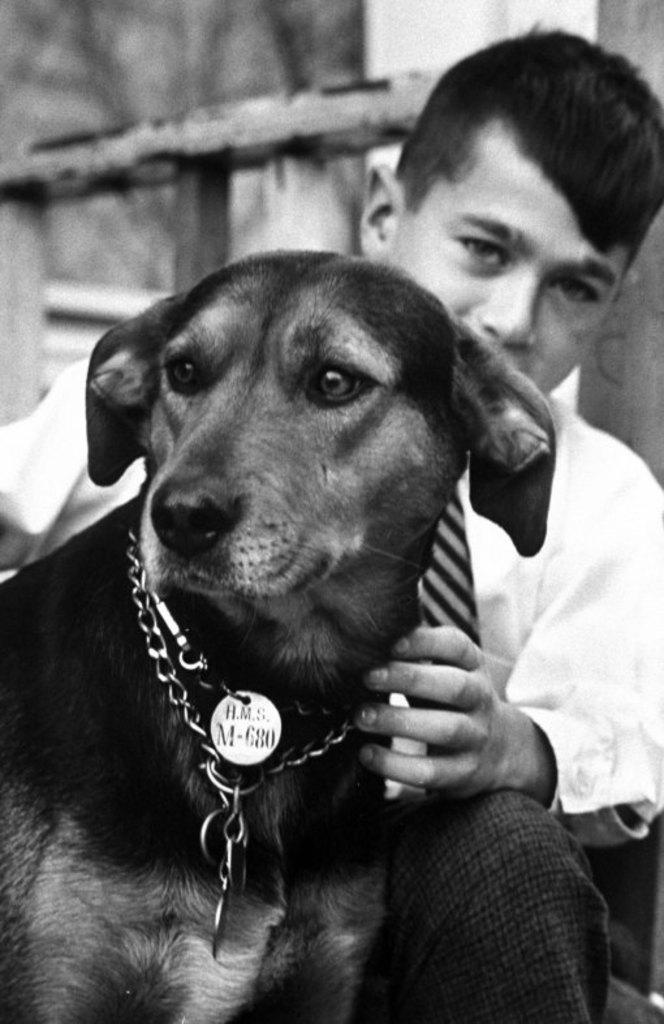What is the color scheme of the image? The image is black and white. Who or what can be seen in the image? There is a boy and a dog in the image. What is the boy doing in the image? The boy is touching the dog. What type of plants can be seen growing in the image? There are no plants visible in the image; it is a black and white image featuring a boy and a dog. How is the pollution affecting the environment in the image? There is no reference to pollution in the image, as it only features a boy and a dog in a black and white setting. 